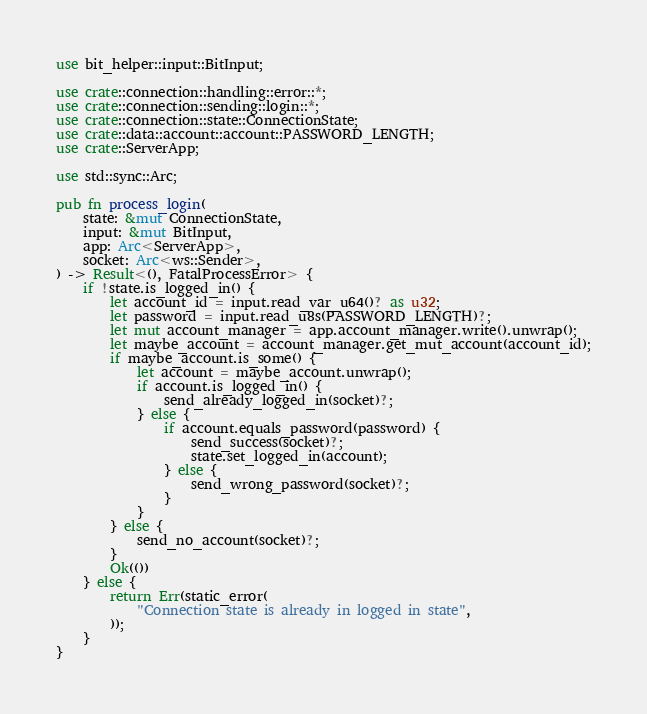<code> <loc_0><loc_0><loc_500><loc_500><_Rust_>use bit_helper::input::BitInput;

use crate::connection::handling::error::*;
use crate::connection::sending::login::*;
use crate::connection::state::ConnectionState;
use crate::data::account::account::PASSWORD_LENGTH;
use crate::ServerApp;

use std::sync::Arc;

pub fn process_login(
    state: &mut ConnectionState,
    input: &mut BitInput,
    app: Arc<ServerApp>,
    socket: Arc<ws::Sender>,
) -> Result<(), FatalProcessError> {
    if !state.is_logged_in() {
        let account_id = input.read_var_u64()? as u32;
        let password = input.read_u8s(PASSWORD_LENGTH)?;
        let mut account_manager = app.account_manager.write().unwrap();
        let maybe_account = account_manager.get_mut_account(account_id);
        if maybe_account.is_some() {
            let account = maybe_account.unwrap();
            if account.is_logged_in() {
                send_already_logged_in(socket)?;
            } else {
                if account.equals_password(password) {
                    send_success(socket)?;
                    state.set_logged_in(account);
                } else {
                    send_wrong_password(socket)?;
                }
            }
        } else {
            send_no_account(socket)?;
        }
        Ok(())
    } else {
        return Err(static_error(
            "Connection state is already in logged in state",
        ));
    }
}
</code> 